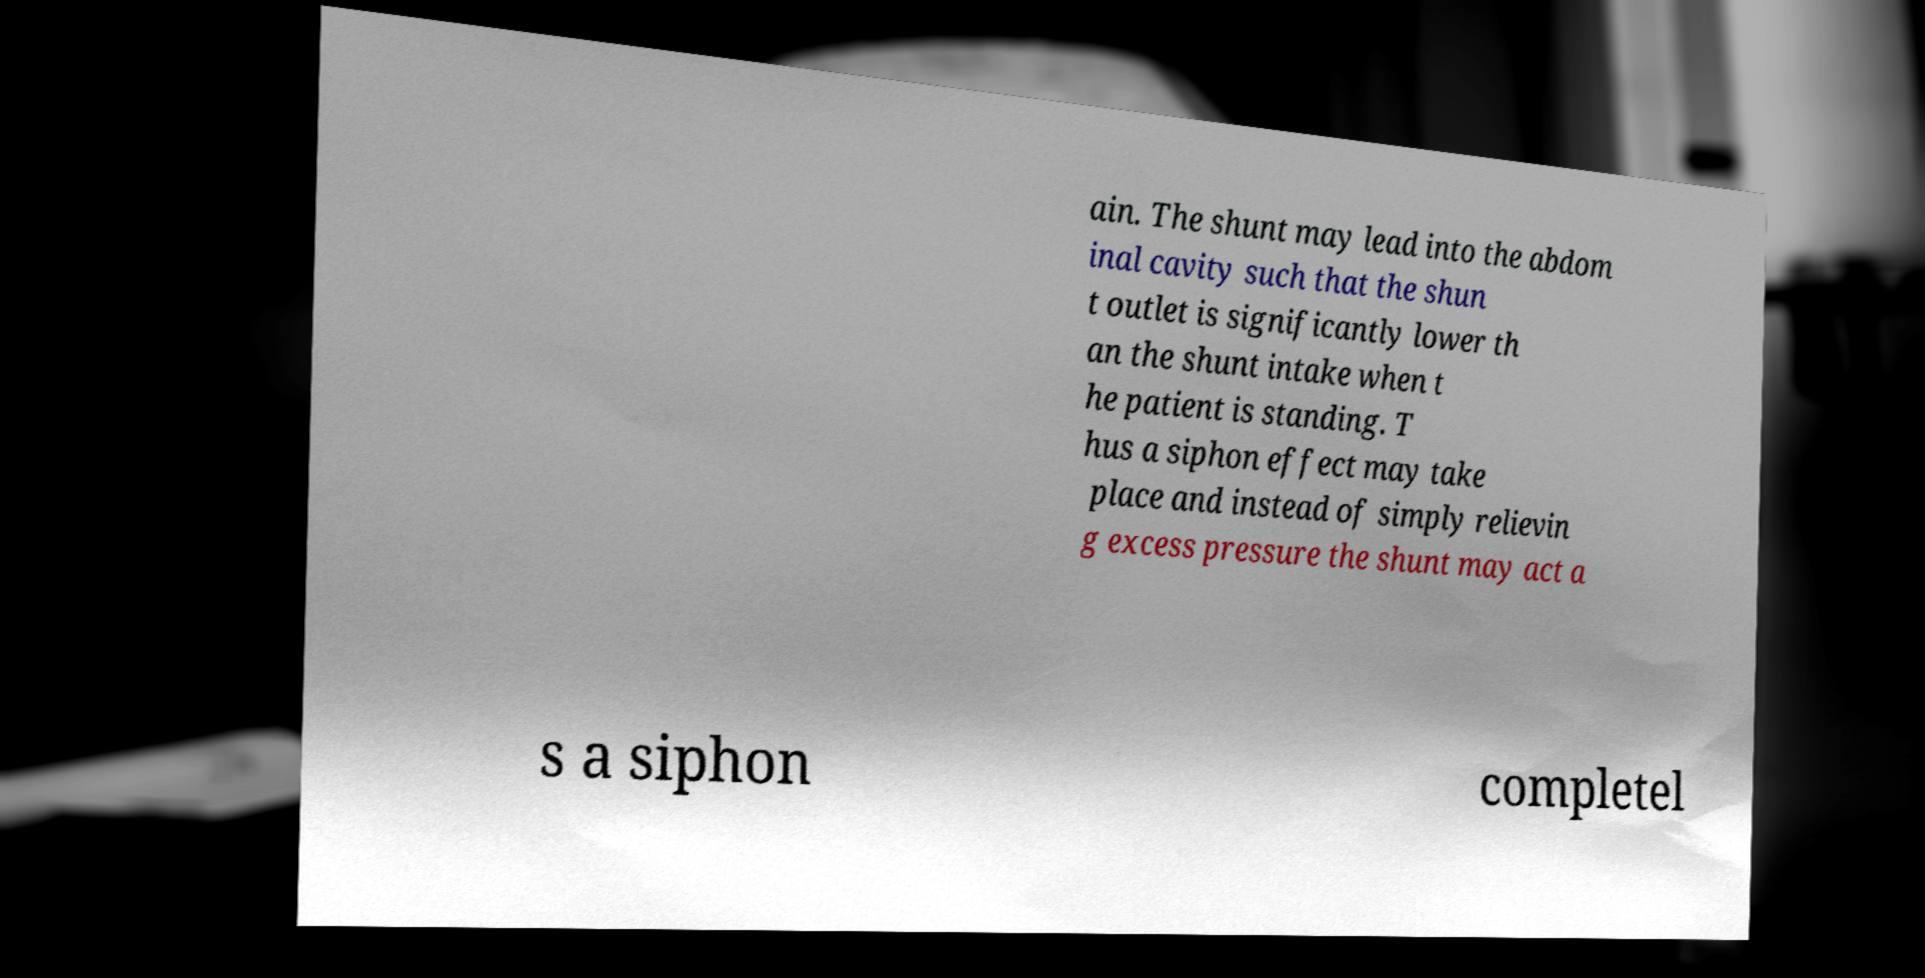Please read and relay the text visible in this image. What does it say? ain. The shunt may lead into the abdom inal cavity such that the shun t outlet is significantly lower th an the shunt intake when t he patient is standing. T hus a siphon effect may take place and instead of simply relievin g excess pressure the shunt may act a s a siphon completel 